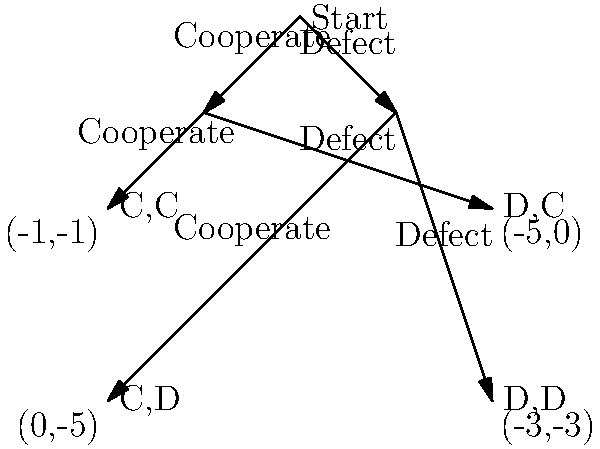In the Prisoner's Dilemma game theory scenario illustrated above, what is the Nash equilibrium, and why does it occur despite not being the optimal outcome for both players? To determine the Nash equilibrium and understand why it occurs, let's follow these steps:

1. Understand the payoffs:
   - If both cooperate (C,C): Both get -1 (1 year in prison each)
   - If one defects and one cooperates (D,C) or (C,D): Defector gets 0, Cooperator gets -5
   - If both defect (D,D): Both get -3 (3 years in prison each)

2. Analyze each player's strategy:
   - For Player 1:
     - If Player 2 cooperates, Player 1 is better off defecting (0 > -1)
     - If Player 2 defects, Player 1 is better off defecting (-3 > -5)
   - For Player 2:
     - If Player 1 cooperates, Player 2 is better off defecting (0 > -1)
     - If Player 1 defects, Player 2 is better off defecting (-3 > -5)

3. Identify the Nash equilibrium:
   The Nash equilibrium occurs when both players defect (D,D), as neither player can unilaterally improve their outcome by changing their strategy.

4. Explain why it's not optimal:
   The Nash equilibrium (D,D) results in both players getting -3, while if they both cooperated (C,C), they would each get -1, which is a better outcome for both.

5. Reason for the dilemma:
   The Nash equilibrium occurs because each player acts in their own self-interest, without the ability to coordinate or trust the other player. Defecting is the dominant strategy for each player, regardless of what the other does, leading to a suboptimal outcome for both.

This scenario demonstrates the tension between individual rationality and collective optimality, which is at the core of many economic and social dilemmas.
Answer: Nash equilibrium: (D,D); occurs due to dominant strategy despite suboptimal collective outcome. 